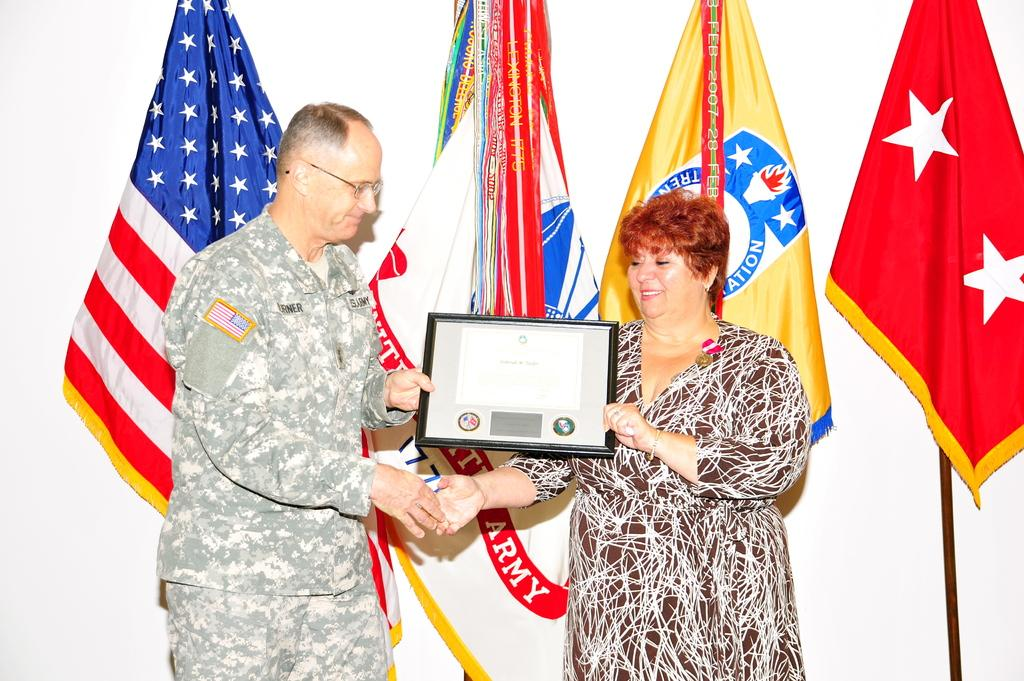Who is the main subject in the image? There is a woman in the image. What is the woman doing in the image? The woman is receiving an award. Who is presenting the award to the woman? An officer is presenting the award. What can be seen in the background of the image? There are four flags visible in the background of the image. What type of pencil can be seen in the woman's hand in the image? There is no pencil present in the woman's hand or in the image. How many cherries are on top of the award in the image? There are no cherries present in the image; the award is not described as having cherries on top. 